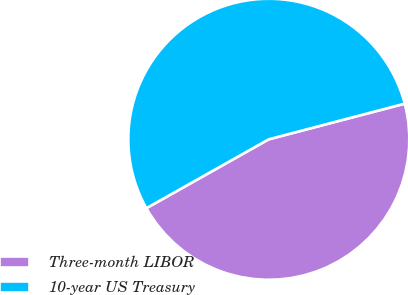Convert chart. <chart><loc_0><loc_0><loc_500><loc_500><pie_chart><fcel>Three-month LIBOR<fcel>10-year US Treasury<nl><fcel>45.92%<fcel>54.08%<nl></chart> 